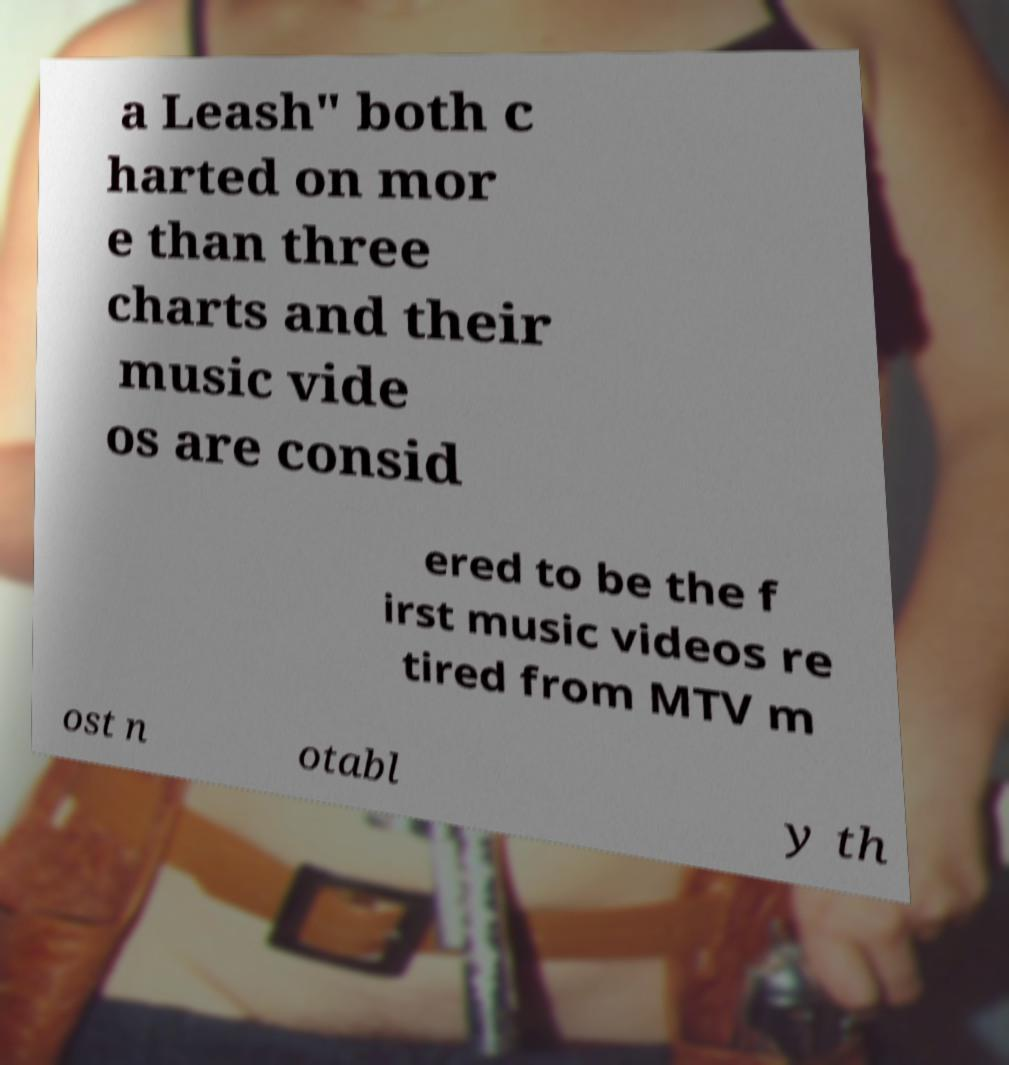I need the written content from this picture converted into text. Can you do that? a Leash" both c harted on mor e than three charts and their music vide os are consid ered to be the f irst music videos re tired from MTV m ost n otabl y th 